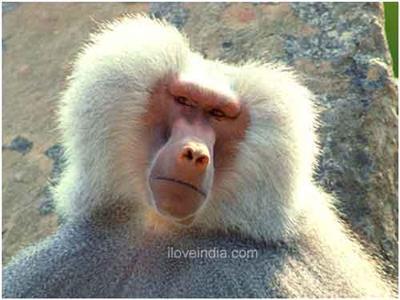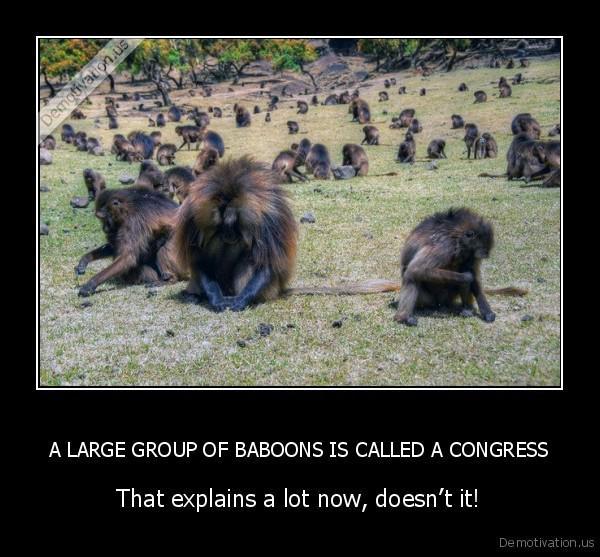The first image is the image on the left, the second image is the image on the right. Analyze the images presented: Is the assertion "One image is framed in black." valid? Answer yes or no. Yes. 